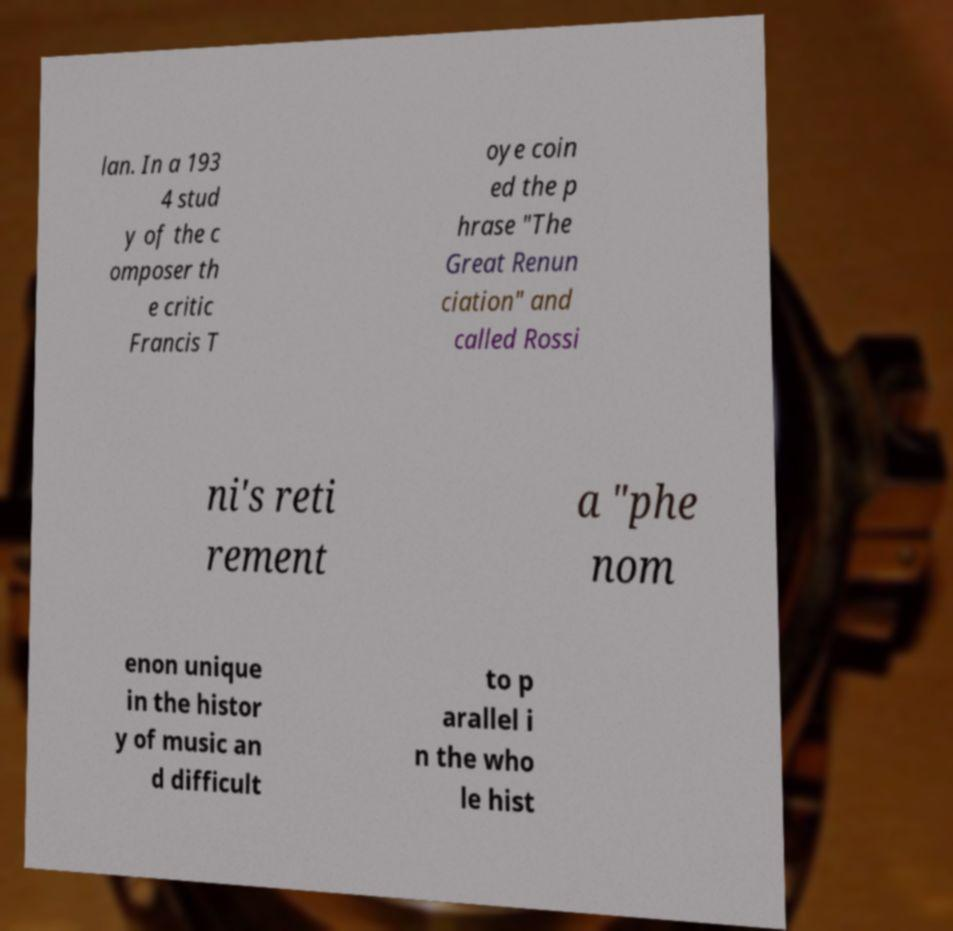There's text embedded in this image that I need extracted. Can you transcribe it verbatim? lan. In a 193 4 stud y of the c omposer th e critic Francis T oye coin ed the p hrase "The Great Renun ciation" and called Rossi ni's reti rement a "phe nom enon unique in the histor y of music an d difficult to p arallel i n the who le hist 